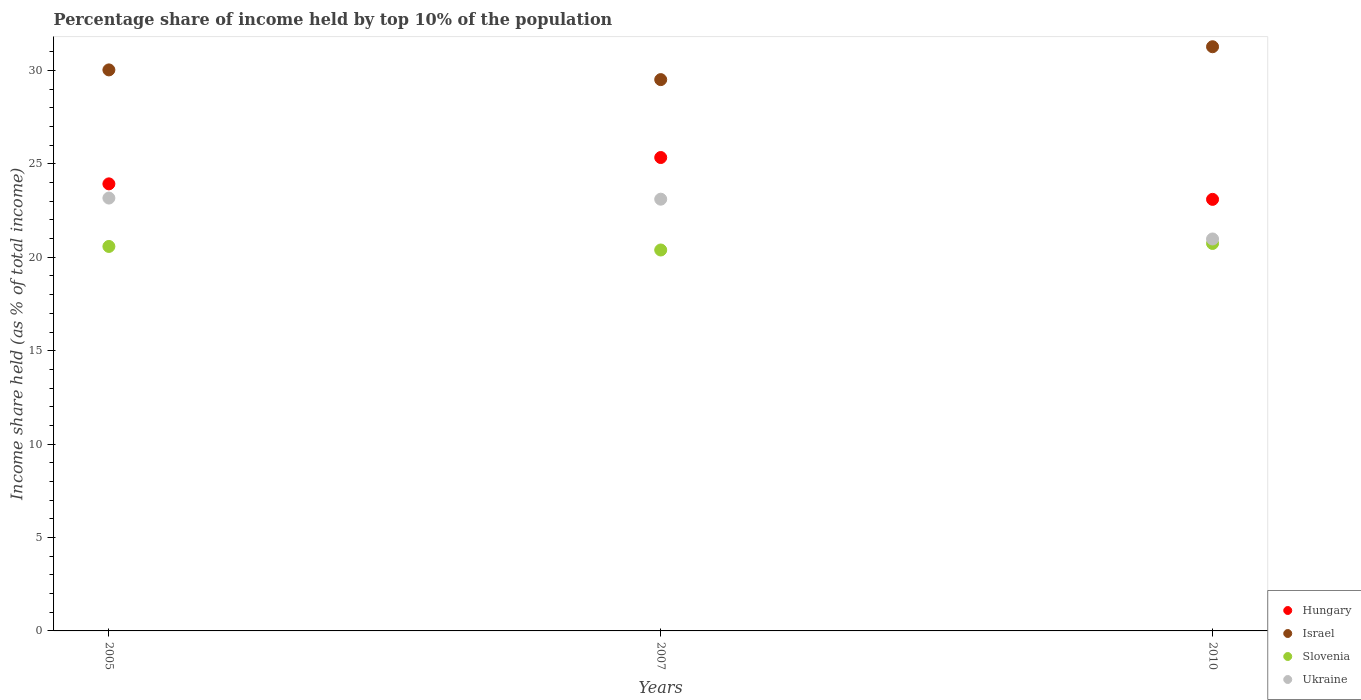What is the percentage share of income held by top 10% of the population in Israel in 2007?
Make the answer very short. 29.51. Across all years, what is the maximum percentage share of income held by top 10% of the population in Hungary?
Offer a very short reply. 25.34. Across all years, what is the minimum percentage share of income held by top 10% of the population in Slovenia?
Provide a succinct answer. 20.39. In which year was the percentage share of income held by top 10% of the population in Ukraine maximum?
Give a very brief answer. 2005. In which year was the percentage share of income held by top 10% of the population in Slovenia minimum?
Your response must be concise. 2007. What is the total percentage share of income held by top 10% of the population in Israel in the graph?
Your answer should be compact. 90.81. What is the difference between the percentage share of income held by top 10% of the population in Israel in 2005 and that in 2007?
Your answer should be compact. 0.52. What is the difference between the percentage share of income held by top 10% of the population in Slovenia in 2007 and the percentage share of income held by top 10% of the population in Hungary in 2010?
Your answer should be very brief. -2.71. What is the average percentage share of income held by top 10% of the population in Hungary per year?
Your response must be concise. 24.12. In the year 2005, what is the difference between the percentage share of income held by top 10% of the population in Slovenia and percentage share of income held by top 10% of the population in Hungary?
Provide a succinct answer. -3.35. In how many years, is the percentage share of income held by top 10% of the population in Israel greater than 24 %?
Give a very brief answer. 3. What is the ratio of the percentage share of income held by top 10% of the population in Slovenia in 2007 to that in 2010?
Your answer should be compact. 0.98. Is the percentage share of income held by top 10% of the population in Slovenia in 2005 less than that in 2007?
Your answer should be very brief. No. What is the difference between the highest and the second highest percentage share of income held by top 10% of the population in Ukraine?
Make the answer very short. 0.06. What is the difference between the highest and the lowest percentage share of income held by top 10% of the population in Ukraine?
Offer a terse response. 2.19. Is it the case that in every year, the sum of the percentage share of income held by top 10% of the population in Israel and percentage share of income held by top 10% of the population in Ukraine  is greater than the percentage share of income held by top 10% of the population in Slovenia?
Your answer should be compact. Yes. Does the percentage share of income held by top 10% of the population in Slovenia monotonically increase over the years?
Your answer should be very brief. No. Is the percentage share of income held by top 10% of the population in Israel strictly less than the percentage share of income held by top 10% of the population in Slovenia over the years?
Make the answer very short. No. How many dotlines are there?
Offer a very short reply. 4. How many years are there in the graph?
Keep it short and to the point. 3. Does the graph contain grids?
Make the answer very short. No. How many legend labels are there?
Offer a terse response. 4. What is the title of the graph?
Provide a succinct answer. Percentage share of income held by top 10% of the population. What is the label or title of the X-axis?
Keep it short and to the point. Years. What is the label or title of the Y-axis?
Your answer should be very brief. Income share held (as % of total income). What is the Income share held (as % of total income) of Hungary in 2005?
Provide a short and direct response. 23.93. What is the Income share held (as % of total income) in Israel in 2005?
Keep it short and to the point. 30.03. What is the Income share held (as % of total income) in Slovenia in 2005?
Your response must be concise. 20.58. What is the Income share held (as % of total income) of Ukraine in 2005?
Offer a very short reply. 23.17. What is the Income share held (as % of total income) of Hungary in 2007?
Your response must be concise. 25.34. What is the Income share held (as % of total income) in Israel in 2007?
Offer a very short reply. 29.51. What is the Income share held (as % of total income) in Slovenia in 2007?
Offer a very short reply. 20.39. What is the Income share held (as % of total income) of Ukraine in 2007?
Ensure brevity in your answer.  23.11. What is the Income share held (as % of total income) of Hungary in 2010?
Keep it short and to the point. 23.1. What is the Income share held (as % of total income) in Israel in 2010?
Offer a terse response. 31.27. What is the Income share held (as % of total income) of Slovenia in 2010?
Provide a succinct answer. 20.74. What is the Income share held (as % of total income) in Ukraine in 2010?
Your answer should be very brief. 20.98. Across all years, what is the maximum Income share held (as % of total income) of Hungary?
Your answer should be compact. 25.34. Across all years, what is the maximum Income share held (as % of total income) of Israel?
Ensure brevity in your answer.  31.27. Across all years, what is the maximum Income share held (as % of total income) in Slovenia?
Ensure brevity in your answer.  20.74. Across all years, what is the maximum Income share held (as % of total income) in Ukraine?
Your answer should be compact. 23.17. Across all years, what is the minimum Income share held (as % of total income) in Hungary?
Your answer should be compact. 23.1. Across all years, what is the minimum Income share held (as % of total income) in Israel?
Your answer should be very brief. 29.51. Across all years, what is the minimum Income share held (as % of total income) in Slovenia?
Your answer should be very brief. 20.39. Across all years, what is the minimum Income share held (as % of total income) in Ukraine?
Your answer should be very brief. 20.98. What is the total Income share held (as % of total income) in Hungary in the graph?
Your answer should be compact. 72.37. What is the total Income share held (as % of total income) in Israel in the graph?
Offer a very short reply. 90.81. What is the total Income share held (as % of total income) in Slovenia in the graph?
Give a very brief answer. 61.71. What is the total Income share held (as % of total income) in Ukraine in the graph?
Provide a short and direct response. 67.26. What is the difference between the Income share held (as % of total income) in Hungary in 2005 and that in 2007?
Provide a short and direct response. -1.41. What is the difference between the Income share held (as % of total income) in Israel in 2005 and that in 2007?
Provide a short and direct response. 0.52. What is the difference between the Income share held (as % of total income) in Slovenia in 2005 and that in 2007?
Ensure brevity in your answer.  0.19. What is the difference between the Income share held (as % of total income) of Hungary in 2005 and that in 2010?
Your answer should be very brief. 0.83. What is the difference between the Income share held (as % of total income) in Israel in 2005 and that in 2010?
Your answer should be compact. -1.24. What is the difference between the Income share held (as % of total income) of Slovenia in 2005 and that in 2010?
Ensure brevity in your answer.  -0.16. What is the difference between the Income share held (as % of total income) in Ukraine in 2005 and that in 2010?
Keep it short and to the point. 2.19. What is the difference between the Income share held (as % of total income) of Hungary in 2007 and that in 2010?
Give a very brief answer. 2.24. What is the difference between the Income share held (as % of total income) of Israel in 2007 and that in 2010?
Your answer should be very brief. -1.76. What is the difference between the Income share held (as % of total income) in Slovenia in 2007 and that in 2010?
Make the answer very short. -0.35. What is the difference between the Income share held (as % of total income) in Ukraine in 2007 and that in 2010?
Offer a terse response. 2.13. What is the difference between the Income share held (as % of total income) of Hungary in 2005 and the Income share held (as % of total income) of Israel in 2007?
Provide a succinct answer. -5.58. What is the difference between the Income share held (as % of total income) in Hungary in 2005 and the Income share held (as % of total income) in Slovenia in 2007?
Ensure brevity in your answer.  3.54. What is the difference between the Income share held (as % of total income) of Hungary in 2005 and the Income share held (as % of total income) of Ukraine in 2007?
Your answer should be very brief. 0.82. What is the difference between the Income share held (as % of total income) in Israel in 2005 and the Income share held (as % of total income) in Slovenia in 2007?
Ensure brevity in your answer.  9.64. What is the difference between the Income share held (as % of total income) in Israel in 2005 and the Income share held (as % of total income) in Ukraine in 2007?
Make the answer very short. 6.92. What is the difference between the Income share held (as % of total income) in Slovenia in 2005 and the Income share held (as % of total income) in Ukraine in 2007?
Ensure brevity in your answer.  -2.53. What is the difference between the Income share held (as % of total income) of Hungary in 2005 and the Income share held (as % of total income) of Israel in 2010?
Your response must be concise. -7.34. What is the difference between the Income share held (as % of total income) in Hungary in 2005 and the Income share held (as % of total income) in Slovenia in 2010?
Your response must be concise. 3.19. What is the difference between the Income share held (as % of total income) of Hungary in 2005 and the Income share held (as % of total income) of Ukraine in 2010?
Offer a terse response. 2.95. What is the difference between the Income share held (as % of total income) of Israel in 2005 and the Income share held (as % of total income) of Slovenia in 2010?
Offer a terse response. 9.29. What is the difference between the Income share held (as % of total income) in Israel in 2005 and the Income share held (as % of total income) in Ukraine in 2010?
Your answer should be very brief. 9.05. What is the difference between the Income share held (as % of total income) in Slovenia in 2005 and the Income share held (as % of total income) in Ukraine in 2010?
Offer a terse response. -0.4. What is the difference between the Income share held (as % of total income) in Hungary in 2007 and the Income share held (as % of total income) in Israel in 2010?
Keep it short and to the point. -5.93. What is the difference between the Income share held (as % of total income) in Hungary in 2007 and the Income share held (as % of total income) in Slovenia in 2010?
Give a very brief answer. 4.6. What is the difference between the Income share held (as % of total income) of Hungary in 2007 and the Income share held (as % of total income) of Ukraine in 2010?
Ensure brevity in your answer.  4.36. What is the difference between the Income share held (as % of total income) in Israel in 2007 and the Income share held (as % of total income) in Slovenia in 2010?
Ensure brevity in your answer.  8.77. What is the difference between the Income share held (as % of total income) in Israel in 2007 and the Income share held (as % of total income) in Ukraine in 2010?
Your answer should be compact. 8.53. What is the difference between the Income share held (as % of total income) of Slovenia in 2007 and the Income share held (as % of total income) of Ukraine in 2010?
Your response must be concise. -0.59. What is the average Income share held (as % of total income) in Hungary per year?
Provide a short and direct response. 24.12. What is the average Income share held (as % of total income) of Israel per year?
Provide a short and direct response. 30.27. What is the average Income share held (as % of total income) of Slovenia per year?
Provide a succinct answer. 20.57. What is the average Income share held (as % of total income) of Ukraine per year?
Ensure brevity in your answer.  22.42. In the year 2005, what is the difference between the Income share held (as % of total income) in Hungary and Income share held (as % of total income) in Israel?
Your response must be concise. -6.1. In the year 2005, what is the difference between the Income share held (as % of total income) in Hungary and Income share held (as % of total income) in Slovenia?
Your answer should be compact. 3.35. In the year 2005, what is the difference between the Income share held (as % of total income) of Hungary and Income share held (as % of total income) of Ukraine?
Give a very brief answer. 0.76. In the year 2005, what is the difference between the Income share held (as % of total income) of Israel and Income share held (as % of total income) of Slovenia?
Ensure brevity in your answer.  9.45. In the year 2005, what is the difference between the Income share held (as % of total income) of Israel and Income share held (as % of total income) of Ukraine?
Provide a succinct answer. 6.86. In the year 2005, what is the difference between the Income share held (as % of total income) in Slovenia and Income share held (as % of total income) in Ukraine?
Offer a very short reply. -2.59. In the year 2007, what is the difference between the Income share held (as % of total income) of Hungary and Income share held (as % of total income) of Israel?
Make the answer very short. -4.17. In the year 2007, what is the difference between the Income share held (as % of total income) of Hungary and Income share held (as % of total income) of Slovenia?
Provide a short and direct response. 4.95. In the year 2007, what is the difference between the Income share held (as % of total income) in Hungary and Income share held (as % of total income) in Ukraine?
Offer a terse response. 2.23. In the year 2007, what is the difference between the Income share held (as % of total income) in Israel and Income share held (as % of total income) in Slovenia?
Ensure brevity in your answer.  9.12. In the year 2007, what is the difference between the Income share held (as % of total income) in Slovenia and Income share held (as % of total income) in Ukraine?
Provide a short and direct response. -2.72. In the year 2010, what is the difference between the Income share held (as % of total income) of Hungary and Income share held (as % of total income) of Israel?
Provide a short and direct response. -8.17. In the year 2010, what is the difference between the Income share held (as % of total income) of Hungary and Income share held (as % of total income) of Slovenia?
Your answer should be very brief. 2.36. In the year 2010, what is the difference between the Income share held (as % of total income) of Hungary and Income share held (as % of total income) of Ukraine?
Ensure brevity in your answer.  2.12. In the year 2010, what is the difference between the Income share held (as % of total income) of Israel and Income share held (as % of total income) of Slovenia?
Your answer should be compact. 10.53. In the year 2010, what is the difference between the Income share held (as % of total income) in Israel and Income share held (as % of total income) in Ukraine?
Offer a terse response. 10.29. In the year 2010, what is the difference between the Income share held (as % of total income) in Slovenia and Income share held (as % of total income) in Ukraine?
Offer a very short reply. -0.24. What is the ratio of the Income share held (as % of total income) of Hungary in 2005 to that in 2007?
Provide a short and direct response. 0.94. What is the ratio of the Income share held (as % of total income) in Israel in 2005 to that in 2007?
Give a very brief answer. 1.02. What is the ratio of the Income share held (as % of total income) in Slovenia in 2005 to that in 2007?
Your answer should be very brief. 1.01. What is the ratio of the Income share held (as % of total income) of Ukraine in 2005 to that in 2007?
Ensure brevity in your answer.  1. What is the ratio of the Income share held (as % of total income) in Hungary in 2005 to that in 2010?
Keep it short and to the point. 1.04. What is the ratio of the Income share held (as % of total income) of Israel in 2005 to that in 2010?
Provide a succinct answer. 0.96. What is the ratio of the Income share held (as % of total income) of Ukraine in 2005 to that in 2010?
Ensure brevity in your answer.  1.1. What is the ratio of the Income share held (as % of total income) in Hungary in 2007 to that in 2010?
Provide a short and direct response. 1.1. What is the ratio of the Income share held (as % of total income) in Israel in 2007 to that in 2010?
Make the answer very short. 0.94. What is the ratio of the Income share held (as % of total income) in Slovenia in 2007 to that in 2010?
Your response must be concise. 0.98. What is the ratio of the Income share held (as % of total income) of Ukraine in 2007 to that in 2010?
Offer a very short reply. 1.1. What is the difference between the highest and the second highest Income share held (as % of total income) in Hungary?
Your answer should be compact. 1.41. What is the difference between the highest and the second highest Income share held (as % of total income) of Israel?
Your response must be concise. 1.24. What is the difference between the highest and the second highest Income share held (as % of total income) in Slovenia?
Keep it short and to the point. 0.16. What is the difference between the highest and the lowest Income share held (as % of total income) of Hungary?
Your response must be concise. 2.24. What is the difference between the highest and the lowest Income share held (as % of total income) in Israel?
Ensure brevity in your answer.  1.76. What is the difference between the highest and the lowest Income share held (as % of total income) of Slovenia?
Provide a succinct answer. 0.35. What is the difference between the highest and the lowest Income share held (as % of total income) in Ukraine?
Provide a short and direct response. 2.19. 